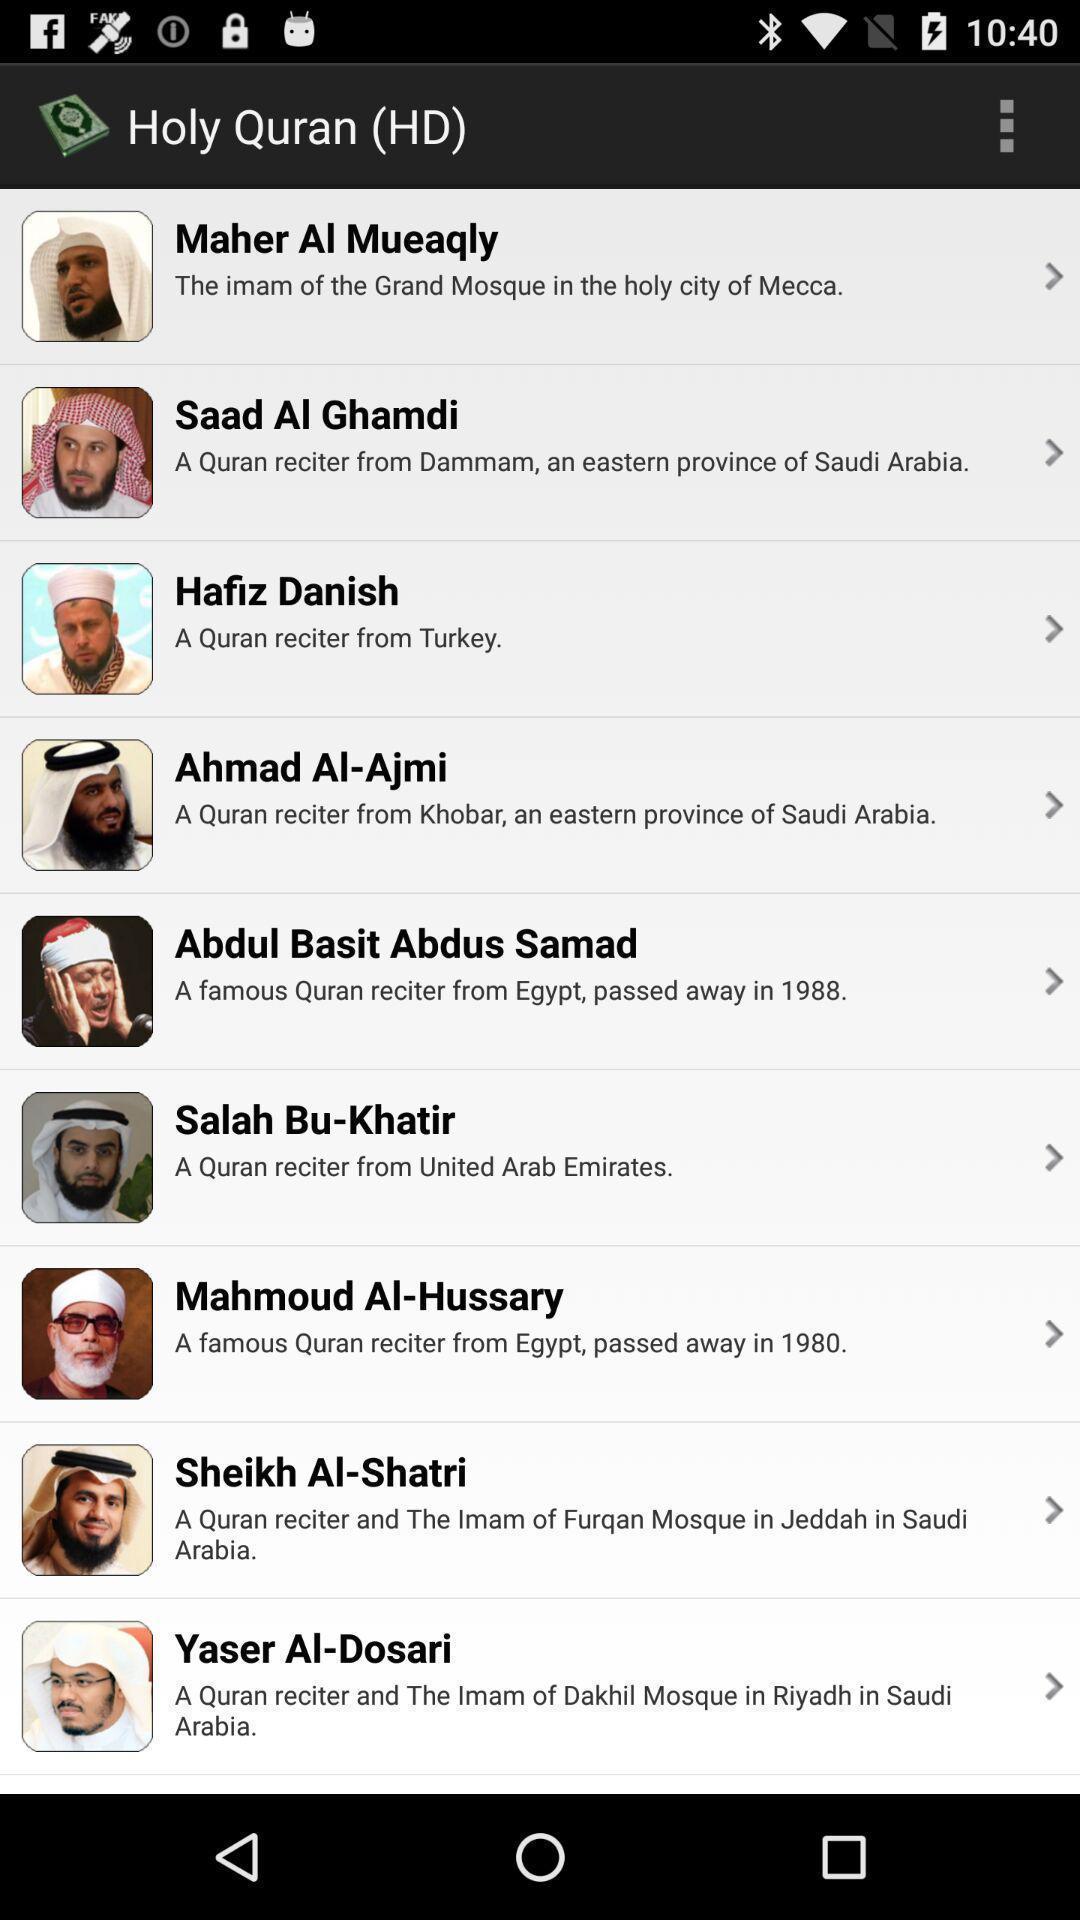Please provide a description for this image. Screen displaying page. 